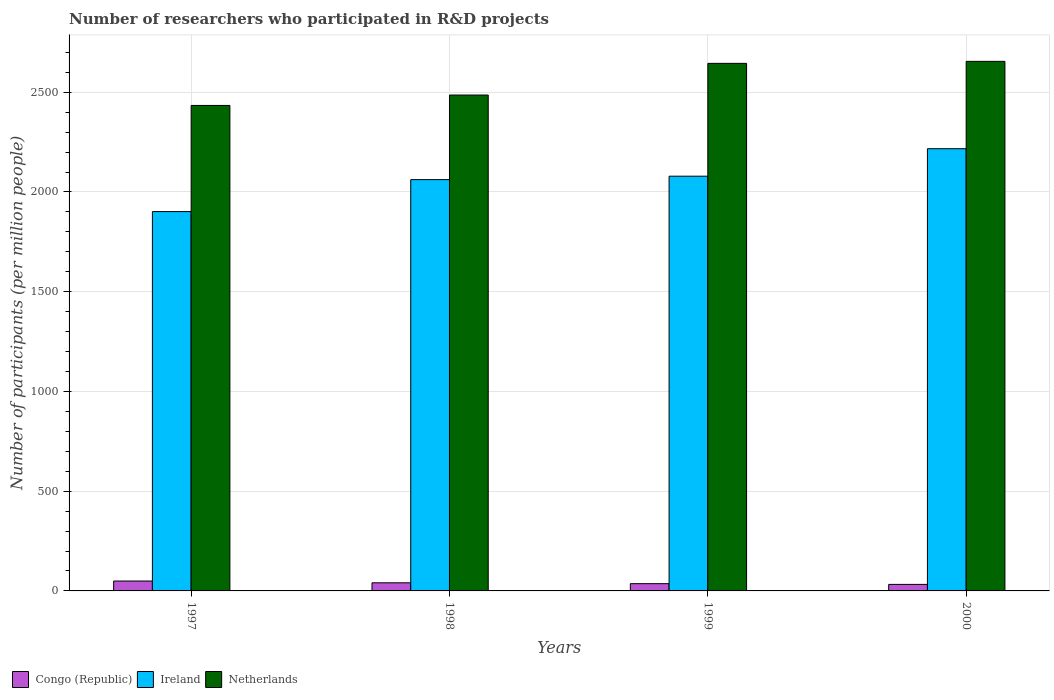How many different coloured bars are there?
Offer a terse response. 3. How many groups of bars are there?
Keep it short and to the point. 4. Are the number of bars on each tick of the X-axis equal?
Your answer should be compact. Yes. How many bars are there on the 3rd tick from the left?
Offer a very short reply. 3. How many bars are there on the 2nd tick from the right?
Your answer should be compact. 3. What is the number of researchers who participated in R&D projects in Netherlands in 1997?
Your answer should be very brief. 2433.66. Across all years, what is the maximum number of researchers who participated in R&D projects in Ireland?
Make the answer very short. 2216.8. Across all years, what is the minimum number of researchers who participated in R&D projects in Ireland?
Make the answer very short. 1901.61. In which year was the number of researchers who participated in R&D projects in Netherlands minimum?
Your answer should be compact. 1997. What is the total number of researchers who participated in R&D projects in Ireland in the graph?
Your answer should be compact. 8259.3. What is the difference between the number of researchers who participated in R&D projects in Ireland in 1999 and that in 2000?
Give a very brief answer. -137.79. What is the difference between the number of researchers who participated in R&D projects in Netherlands in 2000 and the number of researchers who participated in R&D projects in Congo (Republic) in 1997?
Offer a terse response. 2605.12. What is the average number of researchers who participated in R&D projects in Ireland per year?
Ensure brevity in your answer.  2064.83. In the year 2000, what is the difference between the number of researchers who participated in R&D projects in Congo (Republic) and number of researchers who participated in R&D projects in Netherlands?
Your answer should be compact. -2621.99. In how many years, is the number of researchers who participated in R&D projects in Netherlands greater than 1700?
Provide a short and direct response. 4. What is the ratio of the number of researchers who participated in R&D projects in Netherlands in 1998 to that in 1999?
Give a very brief answer. 0.94. What is the difference between the highest and the second highest number of researchers who participated in R&D projects in Netherlands?
Provide a short and direct response. 10.08. What is the difference between the highest and the lowest number of researchers who participated in R&D projects in Ireland?
Provide a short and direct response. 315.18. Is the sum of the number of researchers who participated in R&D projects in Congo (Republic) in 1998 and 2000 greater than the maximum number of researchers who participated in R&D projects in Ireland across all years?
Provide a succinct answer. No. What does the 2nd bar from the left in 1998 represents?
Your response must be concise. Ireland. What does the 3rd bar from the right in 1998 represents?
Give a very brief answer. Congo (Republic). Is it the case that in every year, the sum of the number of researchers who participated in R&D projects in Ireland and number of researchers who participated in R&D projects in Congo (Republic) is greater than the number of researchers who participated in R&D projects in Netherlands?
Provide a short and direct response. No. Are all the bars in the graph horizontal?
Offer a very short reply. No. How many years are there in the graph?
Offer a terse response. 4. Are the values on the major ticks of Y-axis written in scientific E-notation?
Ensure brevity in your answer.  No. Does the graph contain any zero values?
Your answer should be compact. No. Does the graph contain grids?
Provide a succinct answer. Yes. How many legend labels are there?
Your response must be concise. 3. How are the legend labels stacked?
Ensure brevity in your answer.  Horizontal. What is the title of the graph?
Your answer should be very brief. Number of researchers who participated in R&D projects. What is the label or title of the Y-axis?
Ensure brevity in your answer.  Number of participants (per million people). What is the Number of participants (per million people) of Congo (Republic) in 1997?
Provide a short and direct response. 49.59. What is the Number of participants (per million people) in Ireland in 1997?
Make the answer very short. 1901.61. What is the Number of participants (per million people) of Netherlands in 1997?
Provide a succinct answer. 2433.66. What is the Number of participants (per million people) of Congo (Republic) in 1998?
Your answer should be compact. 40.72. What is the Number of participants (per million people) in Ireland in 1998?
Provide a short and direct response. 2061.87. What is the Number of participants (per million people) of Netherlands in 1998?
Your response must be concise. 2485.81. What is the Number of participants (per million people) of Congo (Republic) in 1999?
Your answer should be very brief. 36.36. What is the Number of participants (per million people) in Ireland in 1999?
Provide a succinct answer. 2079.01. What is the Number of participants (per million people) in Netherlands in 1999?
Give a very brief answer. 2644.63. What is the Number of participants (per million people) in Congo (Republic) in 2000?
Ensure brevity in your answer.  32.72. What is the Number of participants (per million people) of Ireland in 2000?
Your answer should be very brief. 2216.8. What is the Number of participants (per million people) of Netherlands in 2000?
Your response must be concise. 2654.71. Across all years, what is the maximum Number of participants (per million people) of Congo (Republic)?
Provide a succinct answer. 49.59. Across all years, what is the maximum Number of participants (per million people) in Ireland?
Offer a terse response. 2216.8. Across all years, what is the maximum Number of participants (per million people) of Netherlands?
Keep it short and to the point. 2654.71. Across all years, what is the minimum Number of participants (per million people) of Congo (Republic)?
Your answer should be very brief. 32.72. Across all years, what is the minimum Number of participants (per million people) in Ireland?
Give a very brief answer. 1901.61. Across all years, what is the minimum Number of participants (per million people) of Netherlands?
Give a very brief answer. 2433.66. What is the total Number of participants (per million people) of Congo (Republic) in the graph?
Provide a short and direct response. 159.4. What is the total Number of participants (per million people) of Ireland in the graph?
Provide a succinct answer. 8259.3. What is the total Number of participants (per million people) in Netherlands in the graph?
Your response must be concise. 1.02e+04. What is the difference between the Number of participants (per million people) in Congo (Republic) in 1997 and that in 1998?
Keep it short and to the point. 8.87. What is the difference between the Number of participants (per million people) of Ireland in 1997 and that in 1998?
Give a very brief answer. -160.26. What is the difference between the Number of participants (per million people) in Netherlands in 1997 and that in 1998?
Your answer should be compact. -52.15. What is the difference between the Number of participants (per million people) in Congo (Republic) in 1997 and that in 1999?
Your answer should be compact. 13.23. What is the difference between the Number of participants (per million people) in Ireland in 1997 and that in 1999?
Your answer should be compact. -177.4. What is the difference between the Number of participants (per million people) of Netherlands in 1997 and that in 1999?
Make the answer very short. -210.97. What is the difference between the Number of participants (per million people) of Congo (Republic) in 1997 and that in 2000?
Make the answer very short. 16.86. What is the difference between the Number of participants (per million people) in Ireland in 1997 and that in 2000?
Offer a very short reply. -315.18. What is the difference between the Number of participants (per million people) in Netherlands in 1997 and that in 2000?
Ensure brevity in your answer.  -221.05. What is the difference between the Number of participants (per million people) in Congo (Republic) in 1998 and that in 1999?
Your response must be concise. 4.36. What is the difference between the Number of participants (per million people) of Ireland in 1998 and that in 1999?
Your answer should be compact. -17.14. What is the difference between the Number of participants (per million people) of Netherlands in 1998 and that in 1999?
Your answer should be very brief. -158.81. What is the difference between the Number of participants (per million people) of Congo (Republic) in 1998 and that in 2000?
Provide a short and direct response. 8. What is the difference between the Number of participants (per million people) of Ireland in 1998 and that in 2000?
Keep it short and to the point. -154.93. What is the difference between the Number of participants (per million people) of Netherlands in 1998 and that in 2000?
Make the answer very short. -168.9. What is the difference between the Number of participants (per million people) in Congo (Republic) in 1999 and that in 2000?
Keep it short and to the point. 3.64. What is the difference between the Number of participants (per million people) of Ireland in 1999 and that in 2000?
Your answer should be compact. -137.79. What is the difference between the Number of participants (per million people) in Netherlands in 1999 and that in 2000?
Make the answer very short. -10.08. What is the difference between the Number of participants (per million people) of Congo (Republic) in 1997 and the Number of participants (per million people) of Ireland in 1998?
Your answer should be very brief. -2012.28. What is the difference between the Number of participants (per million people) in Congo (Republic) in 1997 and the Number of participants (per million people) in Netherlands in 1998?
Keep it short and to the point. -2436.22. What is the difference between the Number of participants (per million people) in Ireland in 1997 and the Number of participants (per million people) in Netherlands in 1998?
Provide a succinct answer. -584.2. What is the difference between the Number of participants (per million people) in Congo (Republic) in 1997 and the Number of participants (per million people) in Ireland in 1999?
Make the answer very short. -2029.42. What is the difference between the Number of participants (per million people) of Congo (Republic) in 1997 and the Number of participants (per million people) of Netherlands in 1999?
Keep it short and to the point. -2595.04. What is the difference between the Number of participants (per million people) in Ireland in 1997 and the Number of participants (per million people) in Netherlands in 1999?
Your response must be concise. -743.01. What is the difference between the Number of participants (per million people) of Congo (Republic) in 1997 and the Number of participants (per million people) of Ireland in 2000?
Your answer should be compact. -2167.21. What is the difference between the Number of participants (per million people) of Congo (Republic) in 1997 and the Number of participants (per million people) of Netherlands in 2000?
Offer a terse response. -2605.12. What is the difference between the Number of participants (per million people) in Ireland in 1997 and the Number of participants (per million people) in Netherlands in 2000?
Give a very brief answer. -753.09. What is the difference between the Number of participants (per million people) of Congo (Republic) in 1998 and the Number of participants (per million people) of Ireland in 1999?
Your answer should be very brief. -2038.29. What is the difference between the Number of participants (per million people) of Congo (Republic) in 1998 and the Number of participants (per million people) of Netherlands in 1999?
Make the answer very short. -2603.91. What is the difference between the Number of participants (per million people) of Ireland in 1998 and the Number of participants (per million people) of Netherlands in 1999?
Ensure brevity in your answer.  -582.75. What is the difference between the Number of participants (per million people) in Congo (Republic) in 1998 and the Number of participants (per million people) in Ireland in 2000?
Ensure brevity in your answer.  -2176.08. What is the difference between the Number of participants (per million people) of Congo (Republic) in 1998 and the Number of participants (per million people) of Netherlands in 2000?
Offer a very short reply. -2613.99. What is the difference between the Number of participants (per million people) in Ireland in 1998 and the Number of participants (per million people) in Netherlands in 2000?
Provide a succinct answer. -592.84. What is the difference between the Number of participants (per million people) in Congo (Republic) in 1999 and the Number of participants (per million people) in Ireland in 2000?
Keep it short and to the point. -2180.44. What is the difference between the Number of participants (per million people) of Congo (Republic) in 1999 and the Number of participants (per million people) of Netherlands in 2000?
Your answer should be very brief. -2618.35. What is the difference between the Number of participants (per million people) of Ireland in 1999 and the Number of participants (per million people) of Netherlands in 2000?
Ensure brevity in your answer.  -575.7. What is the average Number of participants (per million people) in Congo (Republic) per year?
Offer a terse response. 39.85. What is the average Number of participants (per million people) in Ireland per year?
Your answer should be very brief. 2064.83. What is the average Number of participants (per million people) of Netherlands per year?
Give a very brief answer. 2554.7. In the year 1997, what is the difference between the Number of participants (per million people) of Congo (Republic) and Number of participants (per million people) of Ireland?
Your answer should be very brief. -1852.03. In the year 1997, what is the difference between the Number of participants (per million people) in Congo (Republic) and Number of participants (per million people) in Netherlands?
Your answer should be compact. -2384.07. In the year 1997, what is the difference between the Number of participants (per million people) of Ireland and Number of participants (per million people) of Netherlands?
Provide a succinct answer. -532.04. In the year 1998, what is the difference between the Number of participants (per million people) in Congo (Republic) and Number of participants (per million people) in Ireland?
Offer a very short reply. -2021.15. In the year 1998, what is the difference between the Number of participants (per million people) in Congo (Republic) and Number of participants (per million people) in Netherlands?
Your response must be concise. -2445.09. In the year 1998, what is the difference between the Number of participants (per million people) of Ireland and Number of participants (per million people) of Netherlands?
Offer a terse response. -423.94. In the year 1999, what is the difference between the Number of participants (per million people) in Congo (Republic) and Number of participants (per million people) in Ireland?
Your answer should be compact. -2042.65. In the year 1999, what is the difference between the Number of participants (per million people) of Congo (Republic) and Number of participants (per million people) of Netherlands?
Your answer should be compact. -2608.26. In the year 1999, what is the difference between the Number of participants (per million people) of Ireland and Number of participants (per million people) of Netherlands?
Give a very brief answer. -565.61. In the year 2000, what is the difference between the Number of participants (per million people) of Congo (Republic) and Number of participants (per million people) of Ireland?
Make the answer very short. -2184.07. In the year 2000, what is the difference between the Number of participants (per million people) in Congo (Republic) and Number of participants (per million people) in Netherlands?
Make the answer very short. -2621.99. In the year 2000, what is the difference between the Number of participants (per million people) in Ireland and Number of participants (per million people) in Netherlands?
Offer a very short reply. -437.91. What is the ratio of the Number of participants (per million people) of Congo (Republic) in 1997 to that in 1998?
Make the answer very short. 1.22. What is the ratio of the Number of participants (per million people) in Ireland in 1997 to that in 1998?
Ensure brevity in your answer.  0.92. What is the ratio of the Number of participants (per million people) of Netherlands in 1997 to that in 1998?
Provide a short and direct response. 0.98. What is the ratio of the Number of participants (per million people) of Congo (Republic) in 1997 to that in 1999?
Your answer should be compact. 1.36. What is the ratio of the Number of participants (per million people) in Ireland in 1997 to that in 1999?
Your answer should be very brief. 0.91. What is the ratio of the Number of participants (per million people) of Netherlands in 1997 to that in 1999?
Your answer should be very brief. 0.92. What is the ratio of the Number of participants (per million people) in Congo (Republic) in 1997 to that in 2000?
Provide a short and direct response. 1.52. What is the ratio of the Number of participants (per million people) of Ireland in 1997 to that in 2000?
Offer a terse response. 0.86. What is the ratio of the Number of participants (per million people) of Congo (Republic) in 1998 to that in 1999?
Your answer should be very brief. 1.12. What is the ratio of the Number of participants (per million people) in Netherlands in 1998 to that in 1999?
Offer a terse response. 0.94. What is the ratio of the Number of participants (per million people) of Congo (Republic) in 1998 to that in 2000?
Your response must be concise. 1.24. What is the ratio of the Number of participants (per million people) in Ireland in 1998 to that in 2000?
Your answer should be compact. 0.93. What is the ratio of the Number of participants (per million people) in Netherlands in 1998 to that in 2000?
Give a very brief answer. 0.94. What is the ratio of the Number of participants (per million people) of Congo (Republic) in 1999 to that in 2000?
Provide a succinct answer. 1.11. What is the ratio of the Number of participants (per million people) of Ireland in 1999 to that in 2000?
Offer a very short reply. 0.94. What is the ratio of the Number of participants (per million people) of Netherlands in 1999 to that in 2000?
Give a very brief answer. 1. What is the difference between the highest and the second highest Number of participants (per million people) of Congo (Republic)?
Offer a very short reply. 8.87. What is the difference between the highest and the second highest Number of participants (per million people) in Ireland?
Your answer should be very brief. 137.79. What is the difference between the highest and the second highest Number of participants (per million people) of Netherlands?
Provide a short and direct response. 10.08. What is the difference between the highest and the lowest Number of participants (per million people) of Congo (Republic)?
Provide a short and direct response. 16.86. What is the difference between the highest and the lowest Number of participants (per million people) in Ireland?
Make the answer very short. 315.18. What is the difference between the highest and the lowest Number of participants (per million people) in Netherlands?
Offer a terse response. 221.05. 